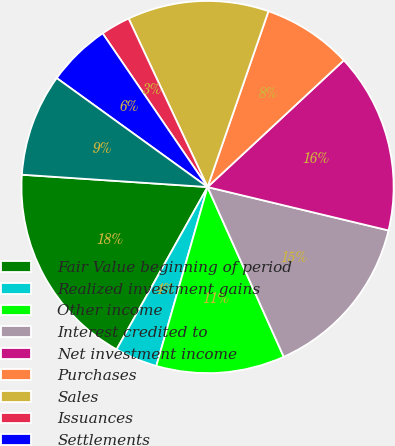Convert chart to OTSL. <chart><loc_0><loc_0><loc_500><loc_500><pie_chart><fcel>Fair Value beginning of period<fcel>Realized investment gains<fcel>Other income<fcel>Interest credited to<fcel>Net investment income<fcel>Purchases<fcel>Sales<fcel>Issuances<fcel>Settlements<fcel>Foreign currency translation<nl><fcel>17.93%<fcel>3.69%<fcel>11.15%<fcel>14.54%<fcel>15.67%<fcel>7.77%<fcel>12.28%<fcel>2.56%<fcel>5.51%<fcel>8.9%<nl></chart> 